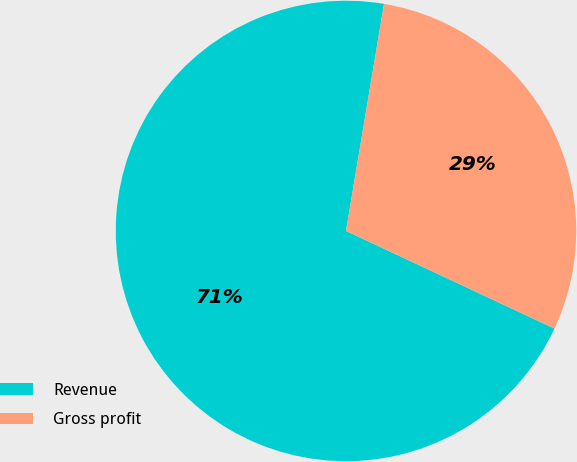<chart> <loc_0><loc_0><loc_500><loc_500><pie_chart><fcel>Revenue<fcel>Gross profit<nl><fcel>70.67%<fcel>29.33%<nl></chart> 